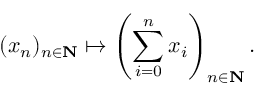Convert formula to latex. <formula><loc_0><loc_0><loc_500><loc_500>( x _ { n } ) _ { n \in N } \mapsto \left ( \sum _ { i = 0 } ^ { n } x _ { i } \right ) _ { n \in N } .</formula> 